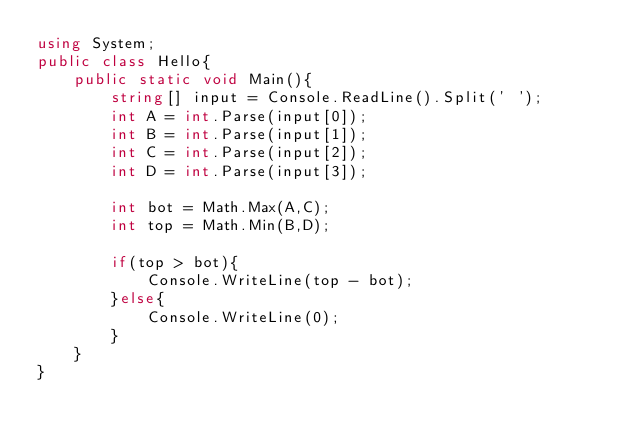<code> <loc_0><loc_0><loc_500><loc_500><_C#_>using System;
public class Hello{
    public static void Main(){
        string[] input = Console.ReadLine().Split(' ');
        int A = int.Parse(input[0]);
        int B = int.Parse(input[1]);
        int C = int.Parse(input[2]);
        int D = int.Parse(input[3]);
        
        int bot = Math.Max(A,C);
        int top = Math.Min(B,D);
        
        if(top > bot){
            Console.WriteLine(top - bot);
        }else{
            Console.WriteLine(0);
        }
    }
}
</code> 